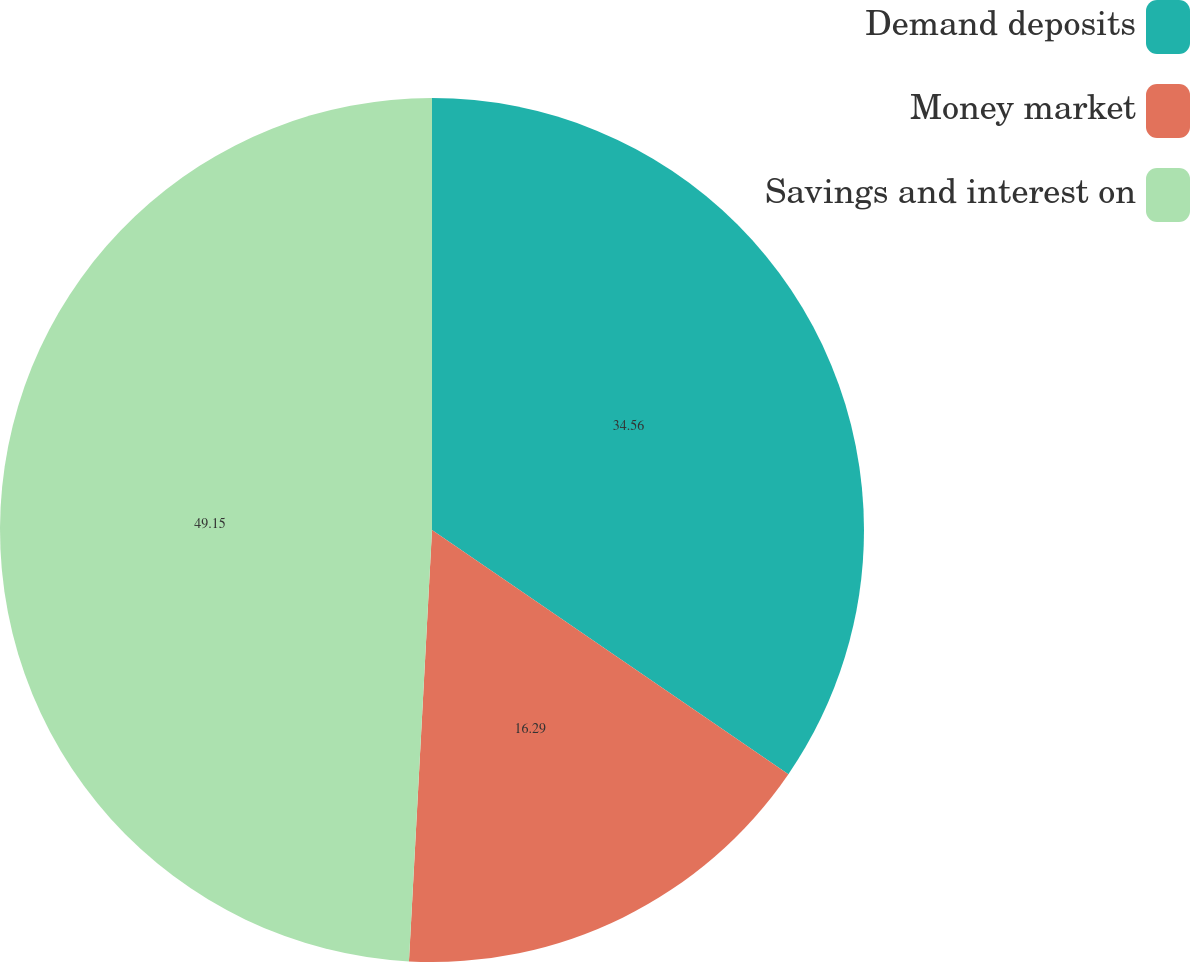Convert chart. <chart><loc_0><loc_0><loc_500><loc_500><pie_chart><fcel>Demand deposits<fcel>Money market<fcel>Savings and interest on<nl><fcel>34.56%<fcel>16.29%<fcel>49.15%<nl></chart> 